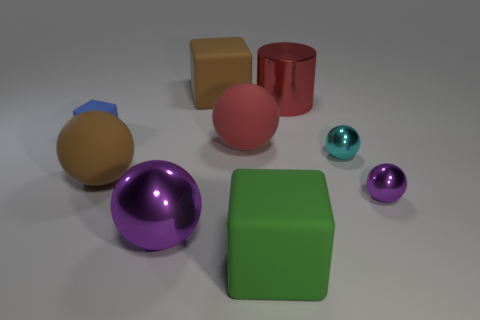Are there more red cylinders that are in front of the cyan object than large red metallic things that are in front of the metallic cylinder?
Keep it short and to the point. No. There is a brown thing in front of the red metallic object; is its size the same as the large green cube?
Give a very brief answer. Yes. There is a purple ball that is left of the large matte block that is behind the large purple sphere; what number of blue rubber things are in front of it?
Give a very brief answer. 0. How big is the cube that is both in front of the cylinder and left of the large green thing?
Keep it short and to the point. Small. How many other things are there of the same shape as the small cyan object?
Your answer should be compact. 4. There is a large cylinder; how many large red spheres are to the left of it?
Offer a terse response. 1. Is the number of matte objects that are in front of the large brown sphere less than the number of red things that are behind the large red cylinder?
Your answer should be compact. No. There is a tiny metal thing that is on the left side of the purple ball on the right side of the big matte block in front of the tiny cyan metal ball; what is its shape?
Ensure brevity in your answer.  Sphere. What is the shape of the object that is both left of the large purple ball and behind the small cyan ball?
Offer a terse response. Cube. Are there any tiny purple objects made of the same material as the blue block?
Your answer should be very brief. No. 